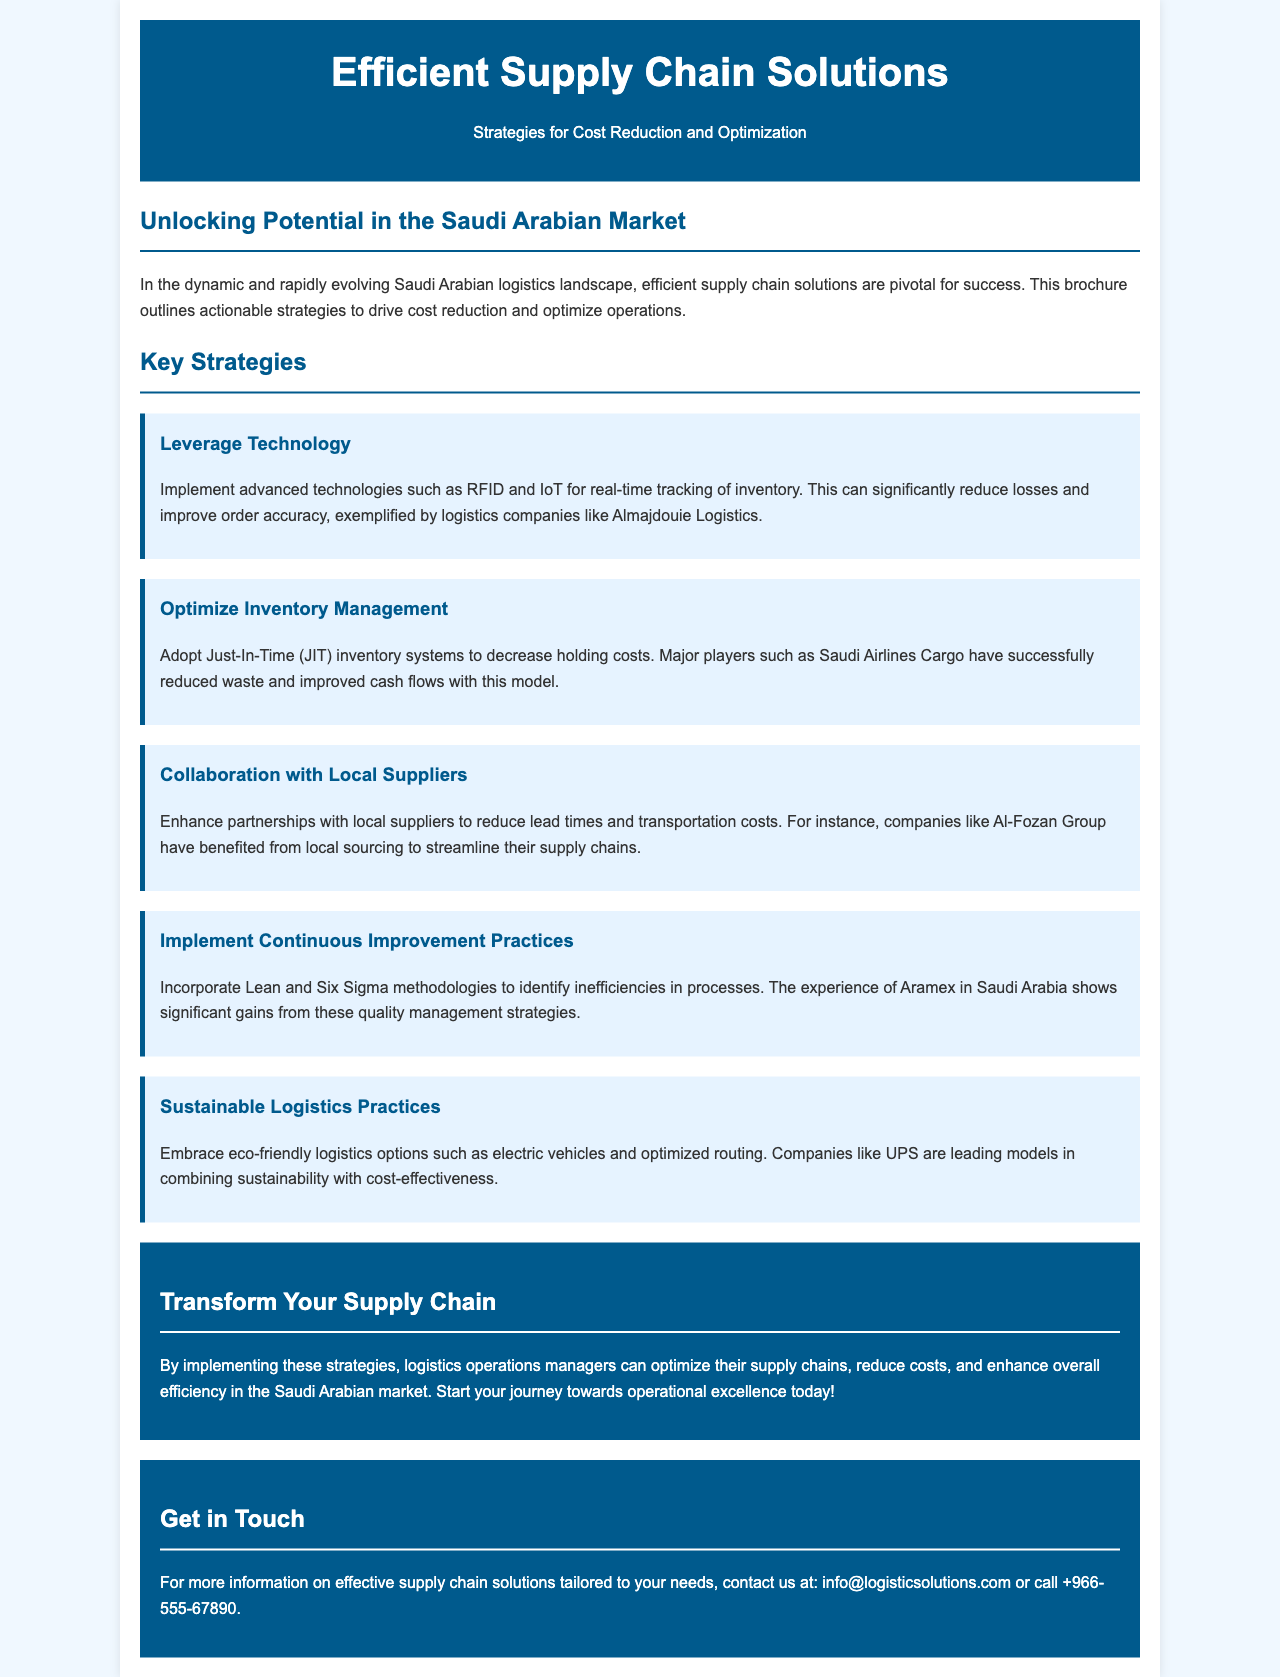What is the title of the brochure? The title of the brochure is prominently displayed at the top of the document.
Answer: Efficient Supply Chain Solutions What is the primary focus of the brochure? The brochure's focus is detailed in the subtitle beneath the title.
Answer: Strategies for Cost Reduction and Optimization Which technology is recommended for real-time tracking of inventory? The specific technology mentioned for tracking inventory is highlighted in the strategy section.
Answer: RFID and IoT Which inventory management system is suggested to decrease holding costs? The suggested inventory management system is a key strategy specifically mentioned in the document.
Answer: Just-In-Time (JIT) What is one of the companies mentioned for benefiting from local sourcing? The company benefiting from local sourcing is noted in the collaboration with local suppliers section.
Answer: Al-Fozan Group What quality management methodologies should be incorporated? The document identifies certain methodologies that can be applied for continuous improvement.
Answer: Lean and Six Sigma Which company is cited as a model in sustainable logistics practices? The company mentioned in the context of sustainable logistics is included in the sustainability practices section.
Answer: UPS What is the contact email provided for more information? The brochure includes a contact email at the bottom for inquiries.
Answer: info@logisticsolutions.com 